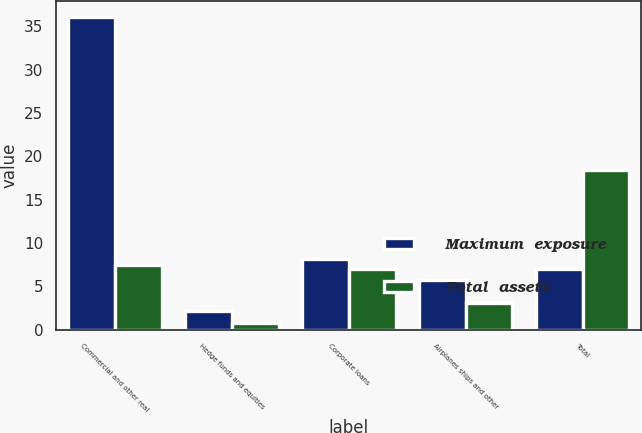Convert chart to OTSL. <chart><loc_0><loc_0><loc_500><loc_500><stacked_bar_chart><ecel><fcel>Commercial and other real<fcel>Hedge funds and equities<fcel>Corporate loans<fcel>Airplanes ships and other<fcel>Total<nl><fcel>Maximum  exposure<fcel>36.1<fcel>2.2<fcel>8.2<fcel>5.7<fcel>7<nl><fcel>Total  assets<fcel>7.5<fcel>0.8<fcel>7<fcel>3.1<fcel>18.4<nl></chart> 